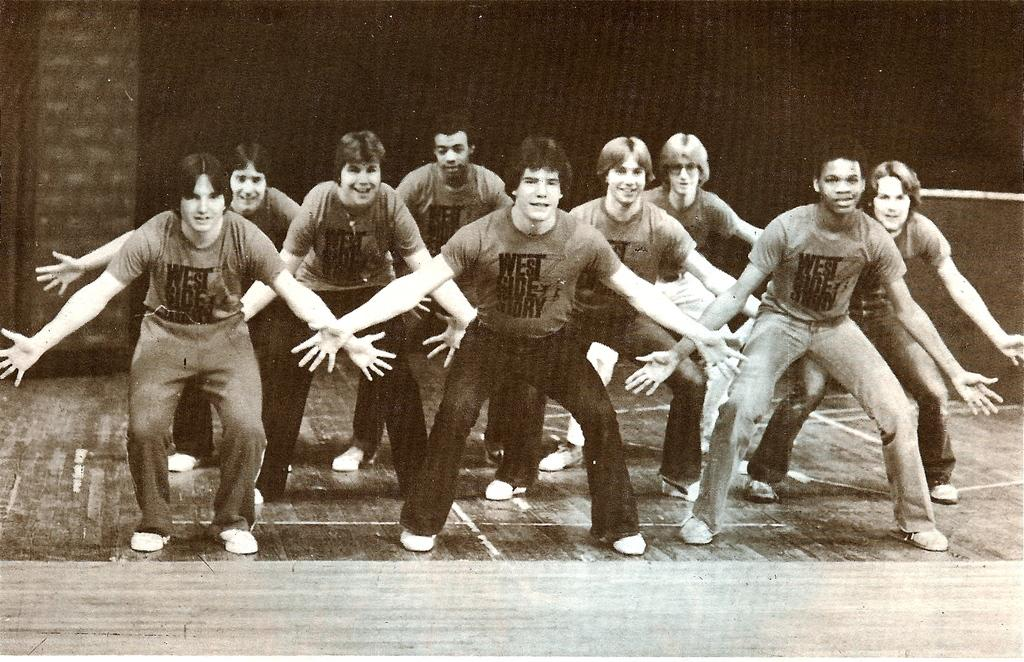What can be seen in the image? There are people standing in the image. Where are the people standing? The people are standing on the floor. What can be seen in the background of the image? There is a wall visible in the background of the image. What type of skin condition can be seen on the people's wrists in the image? There is no skin condition visible on the people's wrists in the image, as the provided facts do not mention any skin conditions or specific body parts. 